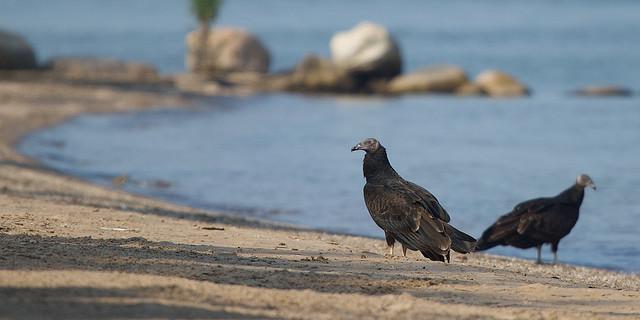Are the vultures eating anything?
Write a very short answer. No. Are these scavengers?
Short answer required. Yes. Where are the rocks?
Quick response, please. Background. What color is the bird?
Answer briefly. Black. Is there any treats for the birds?
Concise answer only. No. Are these birds at the beach?
Give a very brief answer. Yes. 